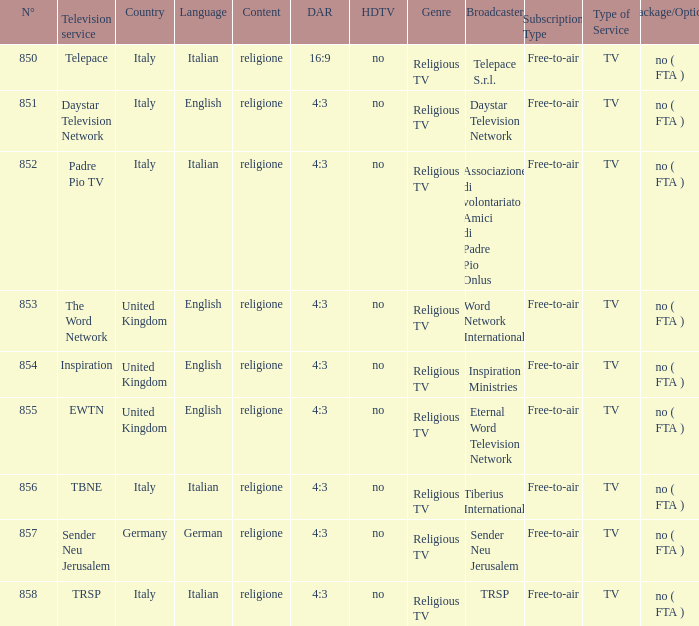What television service are in the united kingdom and n° is greater than 854.0? EWTN. 